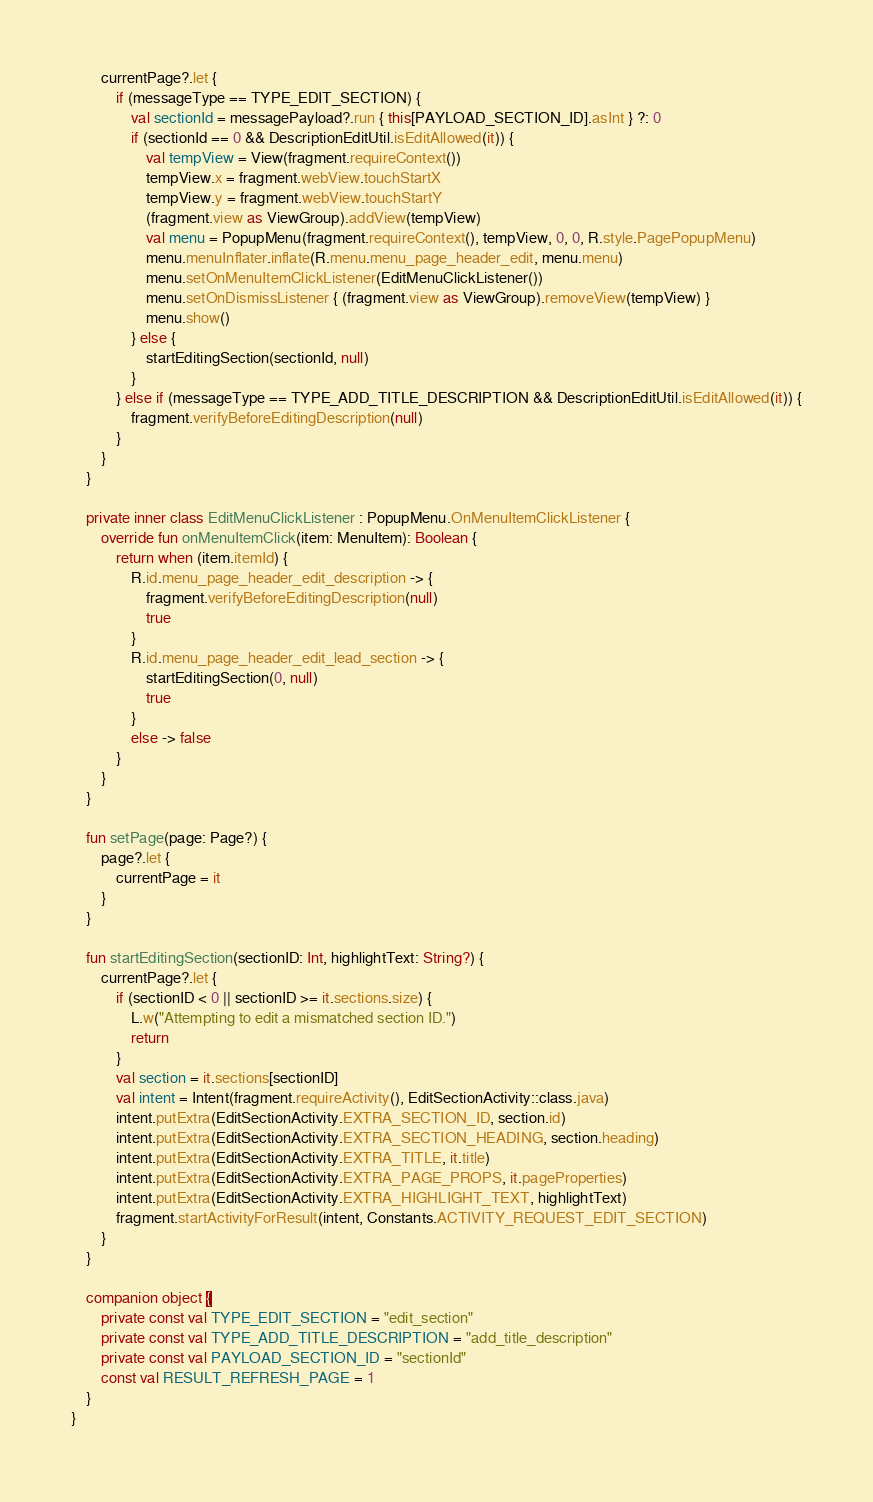<code> <loc_0><loc_0><loc_500><loc_500><_Kotlin_>
        currentPage?.let {
            if (messageType == TYPE_EDIT_SECTION) {
                val sectionId = messagePayload?.run { this[PAYLOAD_SECTION_ID].asInt } ?: 0
                if (sectionId == 0 && DescriptionEditUtil.isEditAllowed(it)) {
                    val tempView = View(fragment.requireContext())
                    tempView.x = fragment.webView.touchStartX
                    tempView.y = fragment.webView.touchStartY
                    (fragment.view as ViewGroup).addView(tempView)
                    val menu = PopupMenu(fragment.requireContext(), tempView, 0, 0, R.style.PagePopupMenu)
                    menu.menuInflater.inflate(R.menu.menu_page_header_edit, menu.menu)
                    menu.setOnMenuItemClickListener(EditMenuClickListener())
                    menu.setOnDismissListener { (fragment.view as ViewGroup).removeView(tempView) }
                    menu.show()
                } else {
                    startEditingSection(sectionId, null)
                }
            } else if (messageType == TYPE_ADD_TITLE_DESCRIPTION && DescriptionEditUtil.isEditAllowed(it)) {
                fragment.verifyBeforeEditingDescription(null)
            }
        }
    }

    private inner class EditMenuClickListener : PopupMenu.OnMenuItemClickListener {
        override fun onMenuItemClick(item: MenuItem): Boolean {
            return when (item.itemId) {
                R.id.menu_page_header_edit_description -> {
                    fragment.verifyBeforeEditingDescription(null)
                    true
                }
                R.id.menu_page_header_edit_lead_section -> {
                    startEditingSection(0, null)
                    true
                }
                else -> false
            }
        }
    }

    fun setPage(page: Page?) {
        page?.let {
            currentPage = it
        }
    }

    fun startEditingSection(sectionID: Int, highlightText: String?) {
        currentPage?.let {
            if (sectionID < 0 || sectionID >= it.sections.size) {
                L.w("Attempting to edit a mismatched section ID.")
                return
            }
            val section = it.sections[sectionID]
            val intent = Intent(fragment.requireActivity(), EditSectionActivity::class.java)
            intent.putExtra(EditSectionActivity.EXTRA_SECTION_ID, section.id)
            intent.putExtra(EditSectionActivity.EXTRA_SECTION_HEADING, section.heading)
            intent.putExtra(EditSectionActivity.EXTRA_TITLE, it.title)
            intent.putExtra(EditSectionActivity.EXTRA_PAGE_PROPS, it.pageProperties)
            intent.putExtra(EditSectionActivity.EXTRA_HIGHLIGHT_TEXT, highlightText)
            fragment.startActivityForResult(intent, Constants.ACTIVITY_REQUEST_EDIT_SECTION)
        }
    }

    companion object {
        private const val TYPE_EDIT_SECTION = "edit_section"
        private const val TYPE_ADD_TITLE_DESCRIPTION = "add_title_description"
        private const val PAYLOAD_SECTION_ID = "sectionId"
        const val RESULT_REFRESH_PAGE = 1
    }
}
</code> 